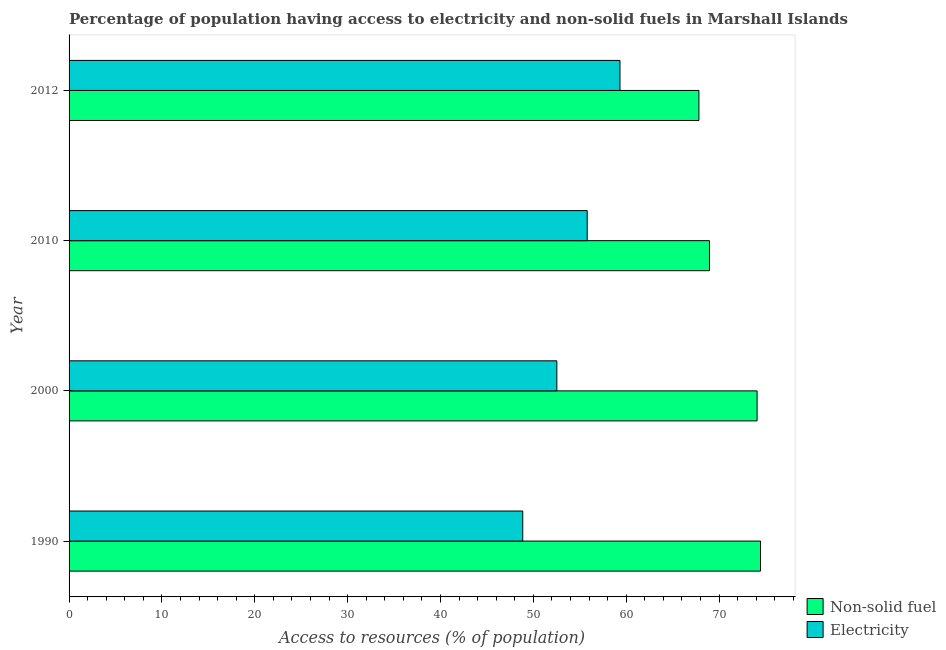Are the number of bars per tick equal to the number of legend labels?
Offer a terse response. Yes. How many bars are there on the 1st tick from the top?
Ensure brevity in your answer.  2. In how many cases, is the number of bars for a given year not equal to the number of legend labels?
Your answer should be very brief. 0. What is the percentage of population having access to electricity in 2012?
Your response must be concise. 59.33. Across all years, what is the maximum percentage of population having access to non-solid fuel?
Provide a short and direct response. 74.47. Across all years, what is the minimum percentage of population having access to electricity?
Your answer should be compact. 48.86. In which year was the percentage of population having access to non-solid fuel minimum?
Keep it short and to the point. 2012. What is the total percentage of population having access to electricity in the graph?
Provide a succinct answer. 216.52. What is the difference between the percentage of population having access to electricity in 1990 and that in 2012?
Keep it short and to the point. -10.47. What is the difference between the percentage of population having access to electricity in 2000 and the percentage of population having access to non-solid fuel in 1990?
Provide a succinct answer. -21.93. What is the average percentage of population having access to electricity per year?
Provide a succinct answer. 54.13. In the year 2000, what is the difference between the percentage of population having access to electricity and percentage of population having access to non-solid fuel?
Give a very brief answer. -21.56. What is the ratio of the percentage of population having access to non-solid fuel in 2000 to that in 2010?
Offer a very short reply. 1.07. Is the percentage of population having access to electricity in 1990 less than that in 2012?
Provide a short and direct response. Yes. Is the difference between the percentage of population having access to non-solid fuel in 2010 and 2012 greater than the difference between the percentage of population having access to electricity in 2010 and 2012?
Give a very brief answer. Yes. What is the difference between the highest and the second highest percentage of population having access to non-solid fuel?
Provide a succinct answer. 0.37. What is the difference between the highest and the lowest percentage of population having access to non-solid fuel?
Give a very brief answer. 6.64. What does the 2nd bar from the top in 1990 represents?
Offer a terse response. Non-solid fuel. What does the 2nd bar from the bottom in 2010 represents?
Keep it short and to the point. Electricity. How many years are there in the graph?
Make the answer very short. 4. What is the difference between two consecutive major ticks on the X-axis?
Offer a terse response. 10. Are the values on the major ticks of X-axis written in scientific E-notation?
Keep it short and to the point. No. Does the graph contain grids?
Provide a short and direct response. No. Where does the legend appear in the graph?
Offer a terse response. Bottom right. How many legend labels are there?
Provide a succinct answer. 2. How are the legend labels stacked?
Your answer should be very brief. Vertical. What is the title of the graph?
Provide a succinct answer. Percentage of population having access to electricity and non-solid fuels in Marshall Islands. What is the label or title of the X-axis?
Offer a terse response. Access to resources (% of population). What is the label or title of the Y-axis?
Your response must be concise. Year. What is the Access to resources (% of population) of Non-solid fuel in 1990?
Make the answer very short. 74.47. What is the Access to resources (% of population) in Electricity in 1990?
Offer a terse response. 48.86. What is the Access to resources (% of population) in Non-solid fuel in 2000?
Make the answer very short. 74.09. What is the Access to resources (% of population) of Electricity in 2000?
Your response must be concise. 52.53. What is the Access to resources (% of population) of Non-solid fuel in 2010?
Keep it short and to the point. 68.97. What is the Access to resources (% of population) of Electricity in 2010?
Provide a succinct answer. 55.8. What is the Access to resources (% of population) in Non-solid fuel in 2012?
Provide a short and direct response. 67.83. What is the Access to resources (% of population) in Electricity in 2012?
Provide a succinct answer. 59.33. Across all years, what is the maximum Access to resources (% of population) of Non-solid fuel?
Your answer should be very brief. 74.47. Across all years, what is the maximum Access to resources (% of population) of Electricity?
Your response must be concise. 59.33. Across all years, what is the minimum Access to resources (% of population) of Non-solid fuel?
Give a very brief answer. 67.83. Across all years, what is the minimum Access to resources (% of population) of Electricity?
Keep it short and to the point. 48.86. What is the total Access to resources (% of population) in Non-solid fuel in the graph?
Ensure brevity in your answer.  285.36. What is the total Access to resources (% of population) of Electricity in the graph?
Your answer should be very brief. 216.52. What is the difference between the Access to resources (% of population) in Non-solid fuel in 1990 and that in 2000?
Your response must be concise. 0.37. What is the difference between the Access to resources (% of population) in Electricity in 1990 and that in 2000?
Your response must be concise. -3.67. What is the difference between the Access to resources (% of population) of Non-solid fuel in 1990 and that in 2010?
Your answer should be compact. 5.5. What is the difference between the Access to resources (% of population) of Electricity in 1990 and that in 2010?
Ensure brevity in your answer.  -6.94. What is the difference between the Access to resources (% of population) of Non-solid fuel in 1990 and that in 2012?
Provide a succinct answer. 6.64. What is the difference between the Access to resources (% of population) of Electricity in 1990 and that in 2012?
Provide a short and direct response. -10.47. What is the difference between the Access to resources (% of population) in Non-solid fuel in 2000 and that in 2010?
Provide a short and direct response. 5.13. What is the difference between the Access to resources (% of population) in Electricity in 2000 and that in 2010?
Your response must be concise. -3.27. What is the difference between the Access to resources (% of population) of Non-solid fuel in 2000 and that in 2012?
Ensure brevity in your answer.  6.27. What is the difference between the Access to resources (% of population) of Electricity in 2000 and that in 2012?
Your response must be concise. -6.8. What is the difference between the Access to resources (% of population) in Non-solid fuel in 2010 and that in 2012?
Keep it short and to the point. 1.14. What is the difference between the Access to resources (% of population) of Electricity in 2010 and that in 2012?
Make the answer very short. -3.53. What is the difference between the Access to resources (% of population) in Non-solid fuel in 1990 and the Access to resources (% of population) in Electricity in 2000?
Your answer should be compact. 21.93. What is the difference between the Access to resources (% of population) of Non-solid fuel in 1990 and the Access to resources (% of population) of Electricity in 2010?
Your response must be concise. 18.67. What is the difference between the Access to resources (% of population) in Non-solid fuel in 1990 and the Access to resources (% of population) in Electricity in 2012?
Your answer should be very brief. 15.14. What is the difference between the Access to resources (% of population) in Non-solid fuel in 2000 and the Access to resources (% of population) in Electricity in 2010?
Offer a terse response. 18.29. What is the difference between the Access to resources (% of population) in Non-solid fuel in 2000 and the Access to resources (% of population) in Electricity in 2012?
Ensure brevity in your answer.  14.77. What is the difference between the Access to resources (% of population) in Non-solid fuel in 2010 and the Access to resources (% of population) in Electricity in 2012?
Provide a short and direct response. 9.64. What is the average Access to resources (% of population) of Non-solid fuel per year?
Keep it short and to the point. 71.34. What is the average Access to resources (% of population) of Electricity per year?
Your answer should be very brief. 54.13. In the year 1990, what is the difference between the Access to resources (% of population) of Non-solid fuel and Access to resources (% of population) of Electricity?
Make the answer very short. 25.61. In the year 2000, what is the difference between the Access to resources (% of population) of Non-solid fuel and Access to resources (% of population) of Electricity?
Provide a short and direct response. 21.56. In the year 2010, what is the difference between the Access to resources (% of population) of Non-solid fuel and Access to resources (% of population) of Electricity?
Offer a very short reply. 13.17. In the year 2012, what is the difference between the Access to resources (% of population) of Non-solid fuel and Access to resources (% of population) of Electricity?
Keep it short and to the point. 8.5. What is the ratio of the Access to resources (% of population) in Non-solid fuel in 1990 to that in 2000?
Provide a short and direct response. 1. What is the ratio of the Access to resources (% of population) of Electricity in 1990 to that in 2000?
Give a very brief answer. 0.93. What is the ratio of the Access to resources (% of population) of Non-solid fuel in 1990 to that in 2010?
Provide a succinct answer. 1.08. What is the ratio of the Access to resources (% of population) of Electricity in 1990 to that in 2010?
Provide a short and direct response. 0.88. What is the ratio of the Access to resources (% of population) of Non-solid fuel in 1990 to that in 2012?
Provide a succinct answer. 1.1. What is the ratio of the Access to resources (% of population) in Electricity in 1990 to that in 2012?
Keep it short and to the point. 0.82. What is the ratio of the Access to resources (% of population) in Non-solid fuel in 2000 to that in 2010?
Your answer should be compact. 1.07. What is the ratio of the Access to resources (% of population) in Electricity in 2000 to that in 2010?
Your answer should be very brief. 0.94. What is the ratio of the Access to resources (% of population) in Non-solid fuel in 2000 to that in 2012?
Offer a very short reply. 1.09. What is the ratio of the Access to resources (% of population) of Electricity in 2000 to that in 2012?
Your answer should be compact. 0.89. What is the ratio of the Access to resources (% of population) of Non-solid fuel in 2010 to that in 2012?
Offer a very short reply. 1.02. What is the ratio of the Access to resources (% of population) of Electricity in 2010 to that in 2012?
Ensure brevity in your answer.  0.94. What is the difference between the highest and the second highest Access to resources (% of population) of Non-solid fuel?
Your answer should be very brief. 0.37. What is the difference between the highest and the second highest Access to resources (% of population) of Electricity?
Ensure brevity in your answer.  3.53. What is the difference between the highest and the lowest Access to resources (% of population) of Non-solid fuel?
Make the answer very short. 6.64. What is the difference between the highest and the lowest Access to resources (% of population) of Electricity?
Offer a terse response. 10.47. 